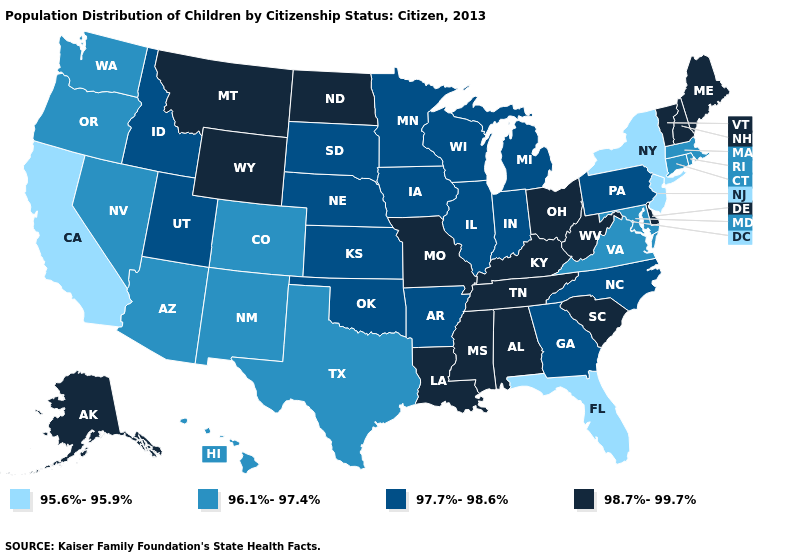Does Missouri have the lowest value in the MidWest?
Give a very brief answer. No. Does Utah have the lowest value in the West?
Quick response, please. No. What is the value of Rhode Island?
Short answer required. 96.1%-97.4%. What is the highest value in states that border Idaho?
Give a very brief answer. 98.7%-99.7%. Which states have the lowest value in the Northeast?
Keep it brief. New Jersey, New York. What is the value of California?
Answer briefly. 95.6%-95.9%. Name the states that have a value in the range 96.1%-97.4%?
Keep it brief. Arizona, Colorado, Connecticut, Hawaii, Maryland, Massachusetts, Nevada, New Mexico, Oregon, Rhode Island, Texas, Virginia, Washington. Among the states that border Arizona , which have the lowest value?
Quick response, please. California. Which states hav the highest value in the South?
Short answer required. Alabama, Delaware, Kentucky, Louisiana, Mississippi, South Carolina, Tennessee, West Virginia. What is the highest value in the USA?
Concise answer only. 98.7%-99.7%. Which states have the lowest value in the West?
Keep it brief. California. What is the value of Pennsylvania?
Be succinct. 97.7%-98.6%. What is the highest value in the West ?
Give a very brief answer. 98.7%-99.7%. Does Georgia have the highest value in the USA?
Short answer required. No. What is the highest value in the MidWest ?
Concise answer only. 98.7%-99.7%. 